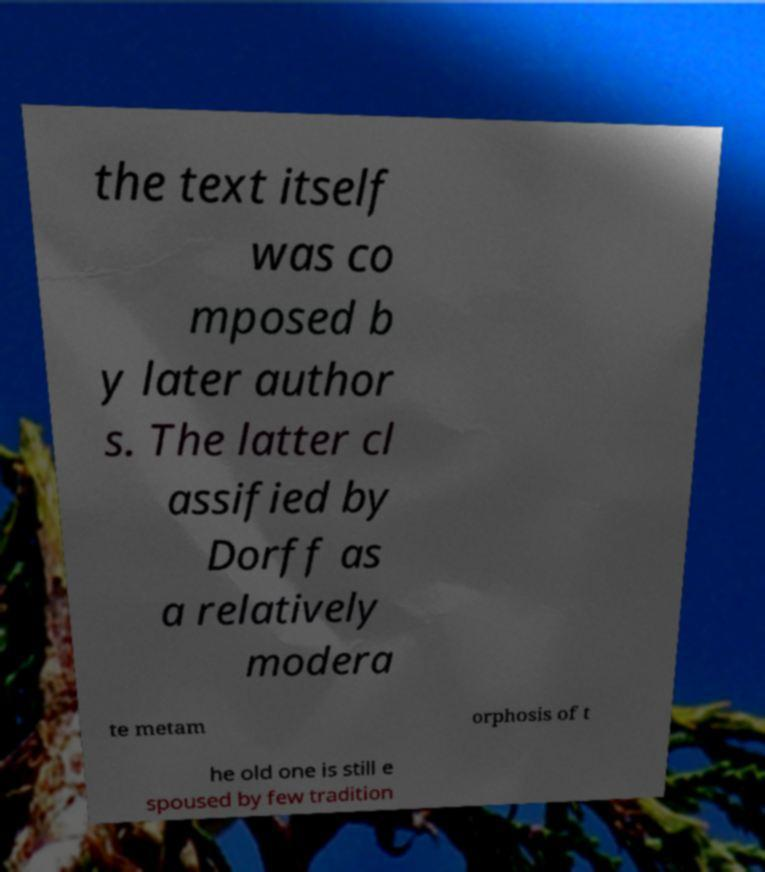Can you accurately transcribe the text from the provided image for me? the text itself was co mposed b y later author s. The latter cl assified by Dorff as a relatively modera te metam orphosis of t he old one is still e spoused by few tradition 